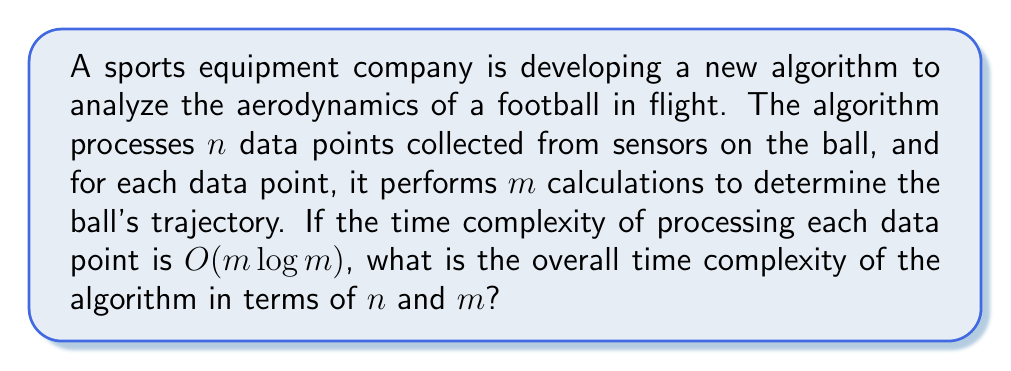Provide a solution to this math problem. To solve this problem, let's break it down step-by-step:

1) First, we need to understand what the question is asking. We're looking for the overall time complexity of an algorithm that:
   - Processes $n$ data points
   - For each data point, performs $m$ calculations
   - The time complexity for processing each data point is $O(m \log m)$

2) Since we're processing $n$ data points, and each data point takes $O(m \log m)$ time to process, we need to multiply these:

   $$O(n \cdot (m \log m))$$

3) This can be rewritten as:

   $$O(nm \log m)$$

4) This is our final answer, as we can't simplify it further without more information about the relationship between $n$ and $m$.

5) In Big O notation, we always consider the worst-case scenario. This complexity means that in the worst case, the time taken by the algorithm grows linearly with $n$ and quasi-linearly with $m$.

6) For a sports-minded individual, we can think of this in terms of game analysis:
   - $n$ could represent the number of plays in a game
   - $m$ could represent the number of players or data points tracked in each play
   The complexity shows how the analysis time grows as we increase the number of plays or the amount of data collected per play.
Answer: $O(nm \log m)$ 